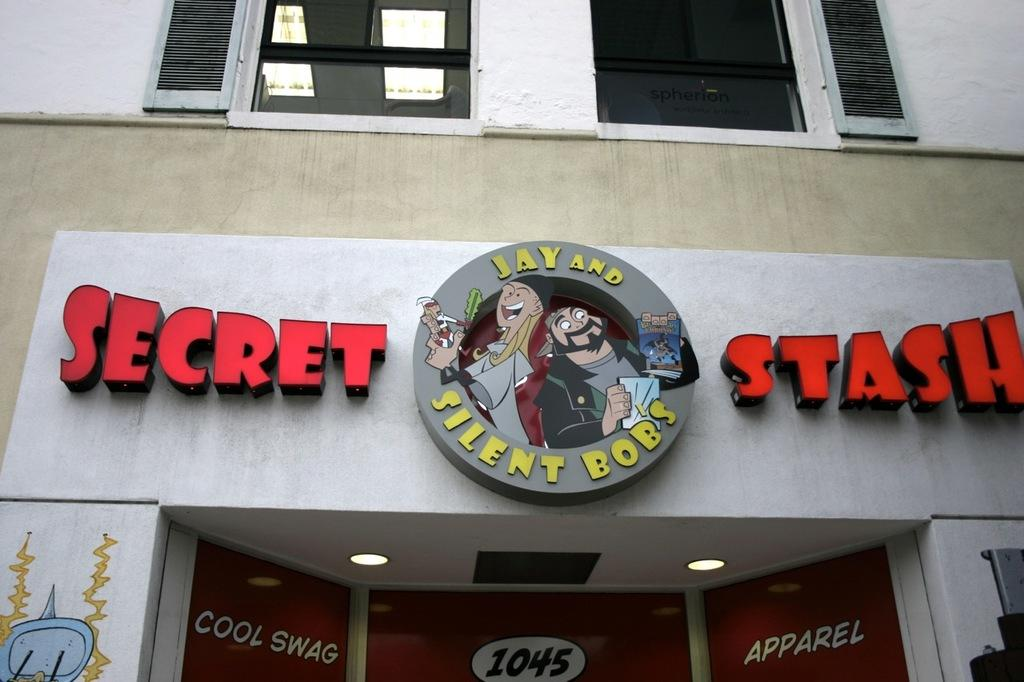What type of structure is present in the image? There is a building in the image. What architectural feature can be seen on the building? There are windows in the image. What additional decorative elements are present in the image? There are banners in the image. How many sisters are depicted holding a pail in the image? There are no sisters or pails present in the image. 